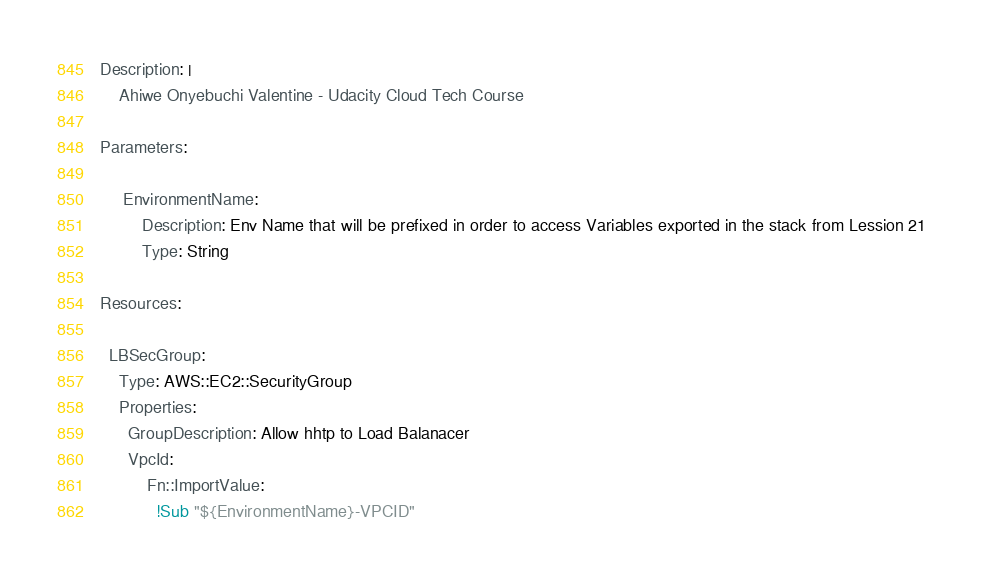Convert code to text. <code><loc_0><loc_0><loc_500><loc_500><_YAML_>Description: |
    Ahiwe Onyebuchi Valentine - Udacity Cloud Tech Course 

Parameters:

     EnvironmentName:
         Description: Env Name that will be prefixed in order to access Variables exported in the stack from Lession 21
         Type: String

Resources:

  LBSecGroup:
    Type: AWS::EC2::SecurityGroup
    Properties: 
      GroupDescription: Allow hhtp to Load Balanacer
      VpcId: 
          Fn::ImportValue:
            !Sub "${EnvironmentName}-VPCID"</code> 